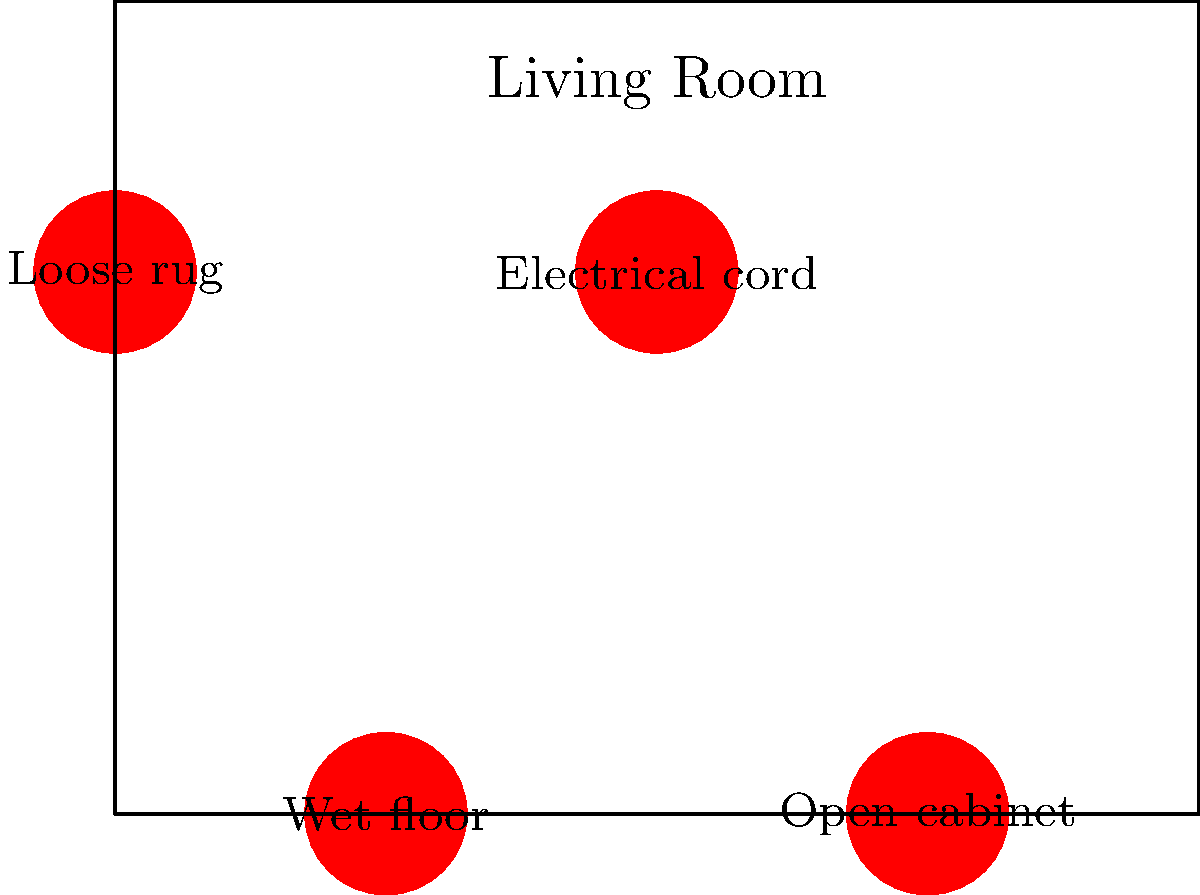In the image above, which household hazard poses the greatest risk of causing a fall for a senior citizen? To determine the greatest fall risk for a senior citizen, let's analyze each hazard:

1. Loose rug: This can easily catch on feet or walkers, causing tripping.
2. Electrical cord: While a tripping hazard, it's usually visible and can be stepped over.
3. Wet floor: This creates a slippery surface, which is particularly dangerous for seniors with balance issues.
4. Open cabinet: While it can cause bumps or bruises, it's less likely to cause a fall than the other hazards.

Considering these factors:
- Loose rugs are a common cause of falls, but they're stationary and visible.
- Electrical cords can be a tripping hazard but are usually visible.
- Wet floors are especially dangerous because they're often not easily visible and affect a larger area.
- Open cabinets are more of a bump hazard than a fall hazard.

The wet floor presents the highest risk because:
1. It's not always easily visible.
2. It affects a larger area than the other hazards.
3. It significantly reduces traction, which is crucial for seniors who may already have balance issues.
4. Even with assistive devices like canes or walkers, a wet floor can cause slipping.

Therefore, the wet floor poses the greatest risk of causing a fall for a senior citizen.
Answer: Wet floor 